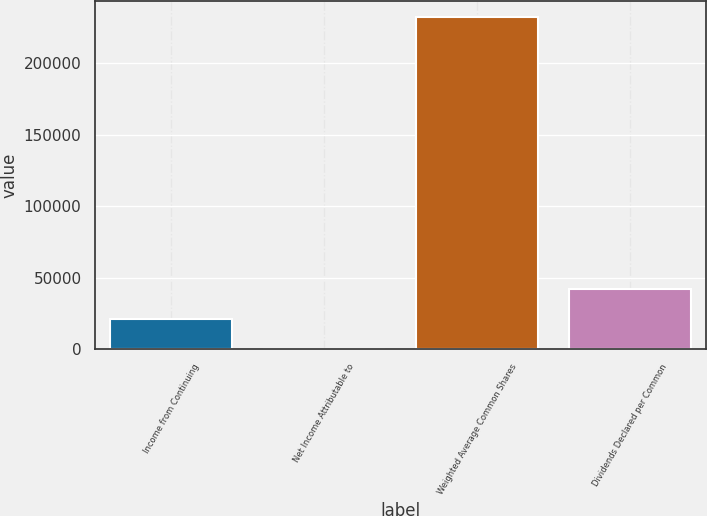Convert chart. <chart><loc_0><loc_0><loc_500><loc_500><bar_chart><fcel>Income from Continuing<fcel>Net Income Attributable to<fcel>Weighted Average Common Shares<fcel>Dividends Declared per Common<nl><fcel>21212.3<fcel>0.58<fcel>231976<fcel>42424.1<nl></chart> 